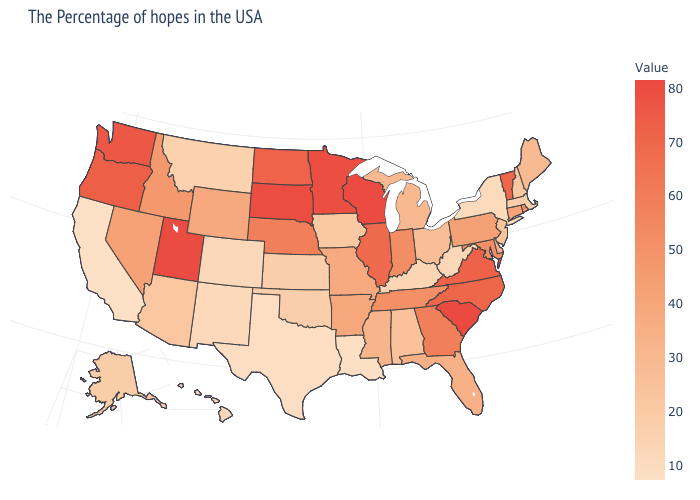Which states hav the highest value in the MidWest?
Be succinct. Wisconsin. Does Utah have the highest value in the West?
Short answer required. Yes. Is the legend a continuous bar?
Be succinct. Yes. Does New Jersey have the highest value in the Northeast?
Write a very short answer. No. Does Wyoming have a higher value than Indiana?
Short answer required. No. Does South Carolina have the highest value in the South?
Give a very brief answer. Yes. 